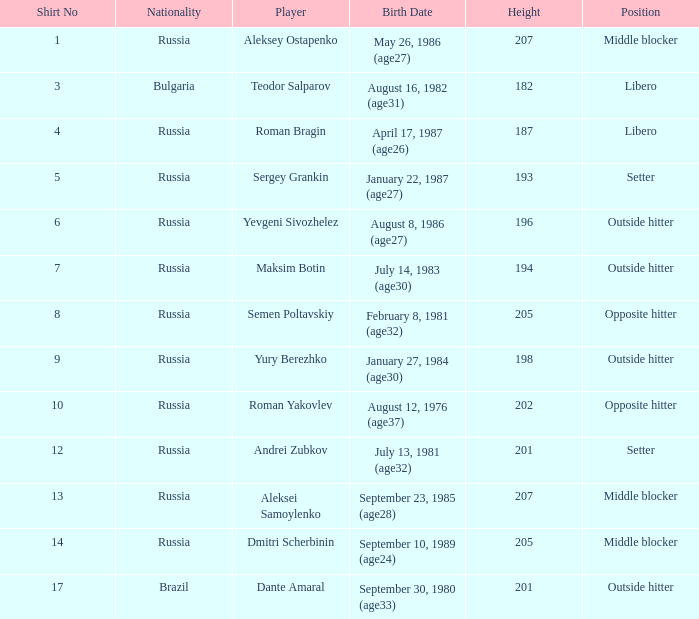How many position does Teodor Salparov play on?  1.0. 